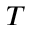<formula> <loc_0><loc_0><loc_500><loc_500>T</formula> 